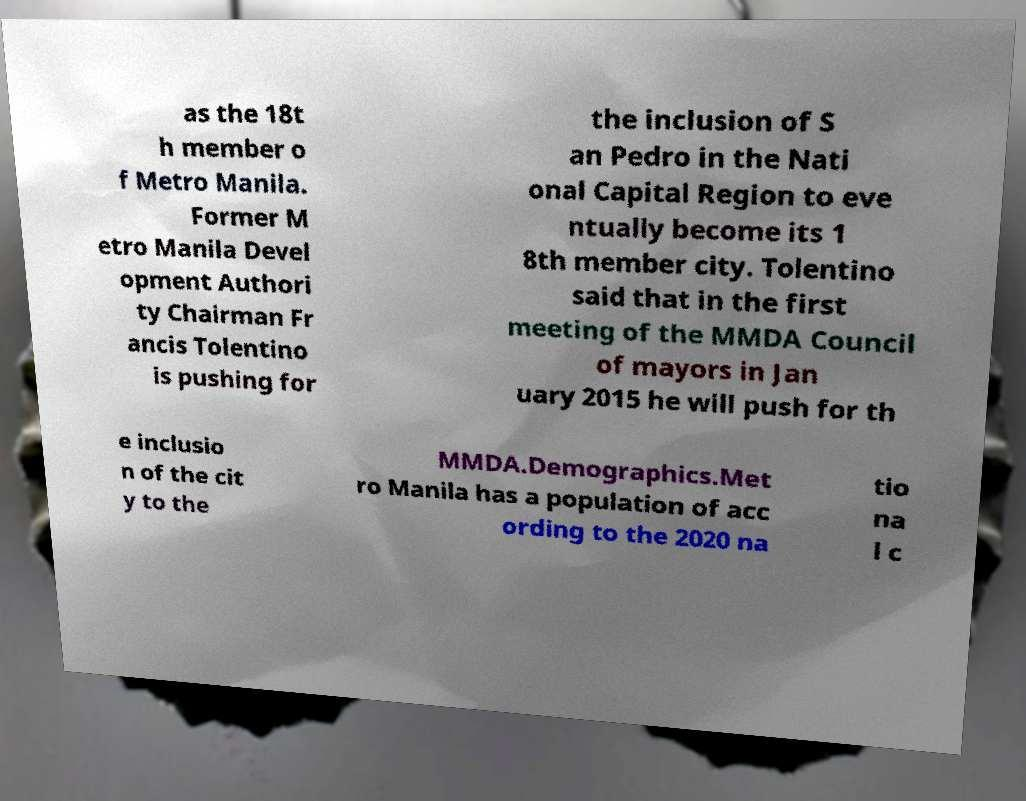Please identify and transcribe the text found in this image. as the 18t h member o f Metro Manila. Former M etro Manila Devel opment Authori ty Chairman Fr ancis Tolentino is pushing for the inclusion of S an Pedro in the Nati onal Capital Region to eve ntually become its 1 8th member city. Tolentino said that in the first meeting of the MMDA Council of mayors in Jan uary 2015 he will push for th e inclusio n of the cit y to the MMDA.Demographics.Met ro Manila has a population of acc ording to the 2020 na tio na l c 